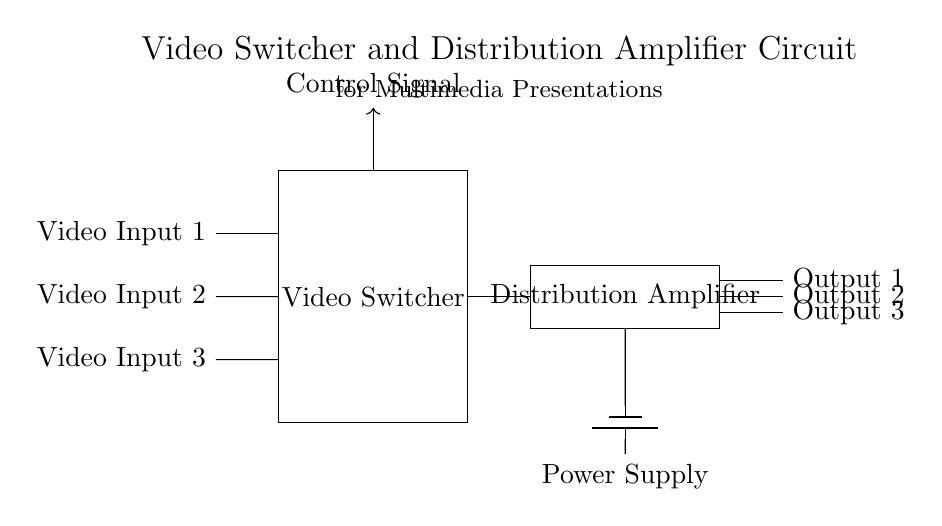What are the input sources in this circuit? The circuit diagram shows three video input sources labeled Video Input 1, Video Input 2, and Video Input 3, indicating they are the inputs feeding into the video switcher.
Answer: Video Input 1, Video Input 2, Video Input 3 What component is used for switching the video signals? The circuit diagram includes a section labeled "Video Switcher," indicating that this is the component responsible for selecting and switching between the different video input sources.
Answer: Video Switcher How many output connections does the distribution amplifier have? The circuit diagram shows three output lines emanating from the "Distribution Amplifier" component, indicating that it has three output connections available for distribution.
Answer: Three What controls the video switcher? The diagram indicates a "Control Signal" arrow directed towards the video switcher, suggesting that it is controlled by external signals directing which input source is selected.
Answer: Control Signal What is the function of the power supply in this circuit? The "Power Supply" in the circuit diagram is connected to the "Distribution Amplifier" and provides the necessary electrical power for its operation, ensuring it can amplify the video signals effectively.
Answer: Power Supply What is the purpose of the distribution amplifier in this circuit? The distribution amplifier is responsible for taking the switched video signal and amplifying it to ensure it can be sent to multiple outputs without signal degradation.
Answer: Amplification 